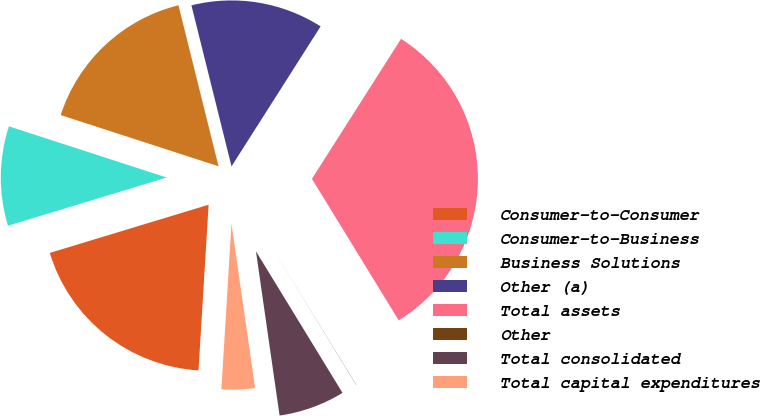<chart> <loc_0><loc_0><loc_500><loc_500><pie_chart><fcel>Consumer-to-Consumer<fcel>Consumer-to-Business<fcel>Business Solutions<fcel>Other (a)<fcel>Total assets<fcel>Other<fcel>Total consolidated<fcel>Total capital expenditures<nl><fcel>19.34%<fcel>9.68%<fcel>16.12%<fcel>12.9%<fcel>32.22%<fcel>0.02%<fcel>6.46%<fcel>3.24%<nl></chart> 